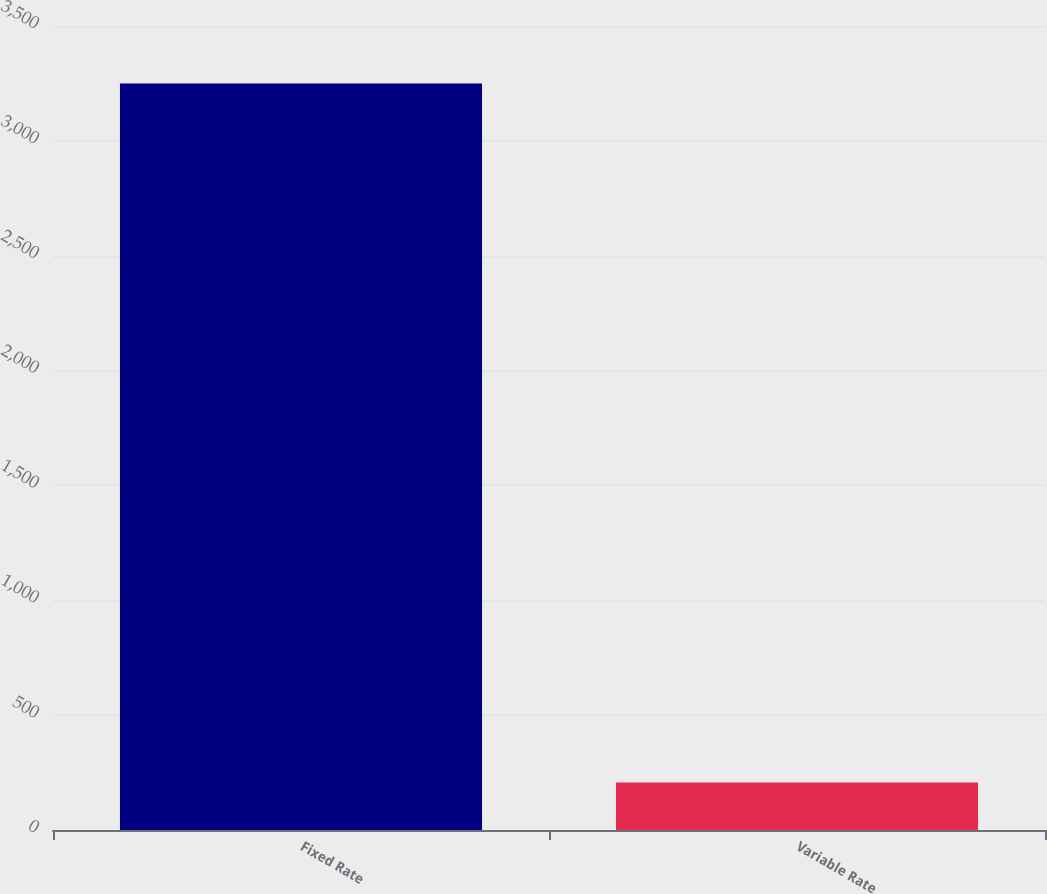Convert chart. <chart><loc_0><loc_0><loc_500><loc_500><bar_chart><fcel>Fixed Rate<fcel>Variable Rate<nl><fcel>3250<fcel>207<nl></chart> 